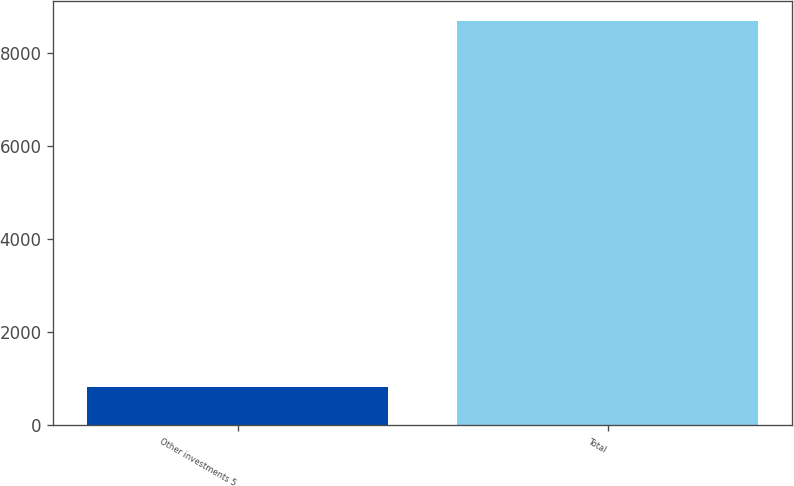Convert chart. <chart><loc_0><loc_0><loc_500><loc_500><bar_chart><fcel>Other investments 5<fcel>Total<nl><fcel>822<fcel>8676<nl></chart> 